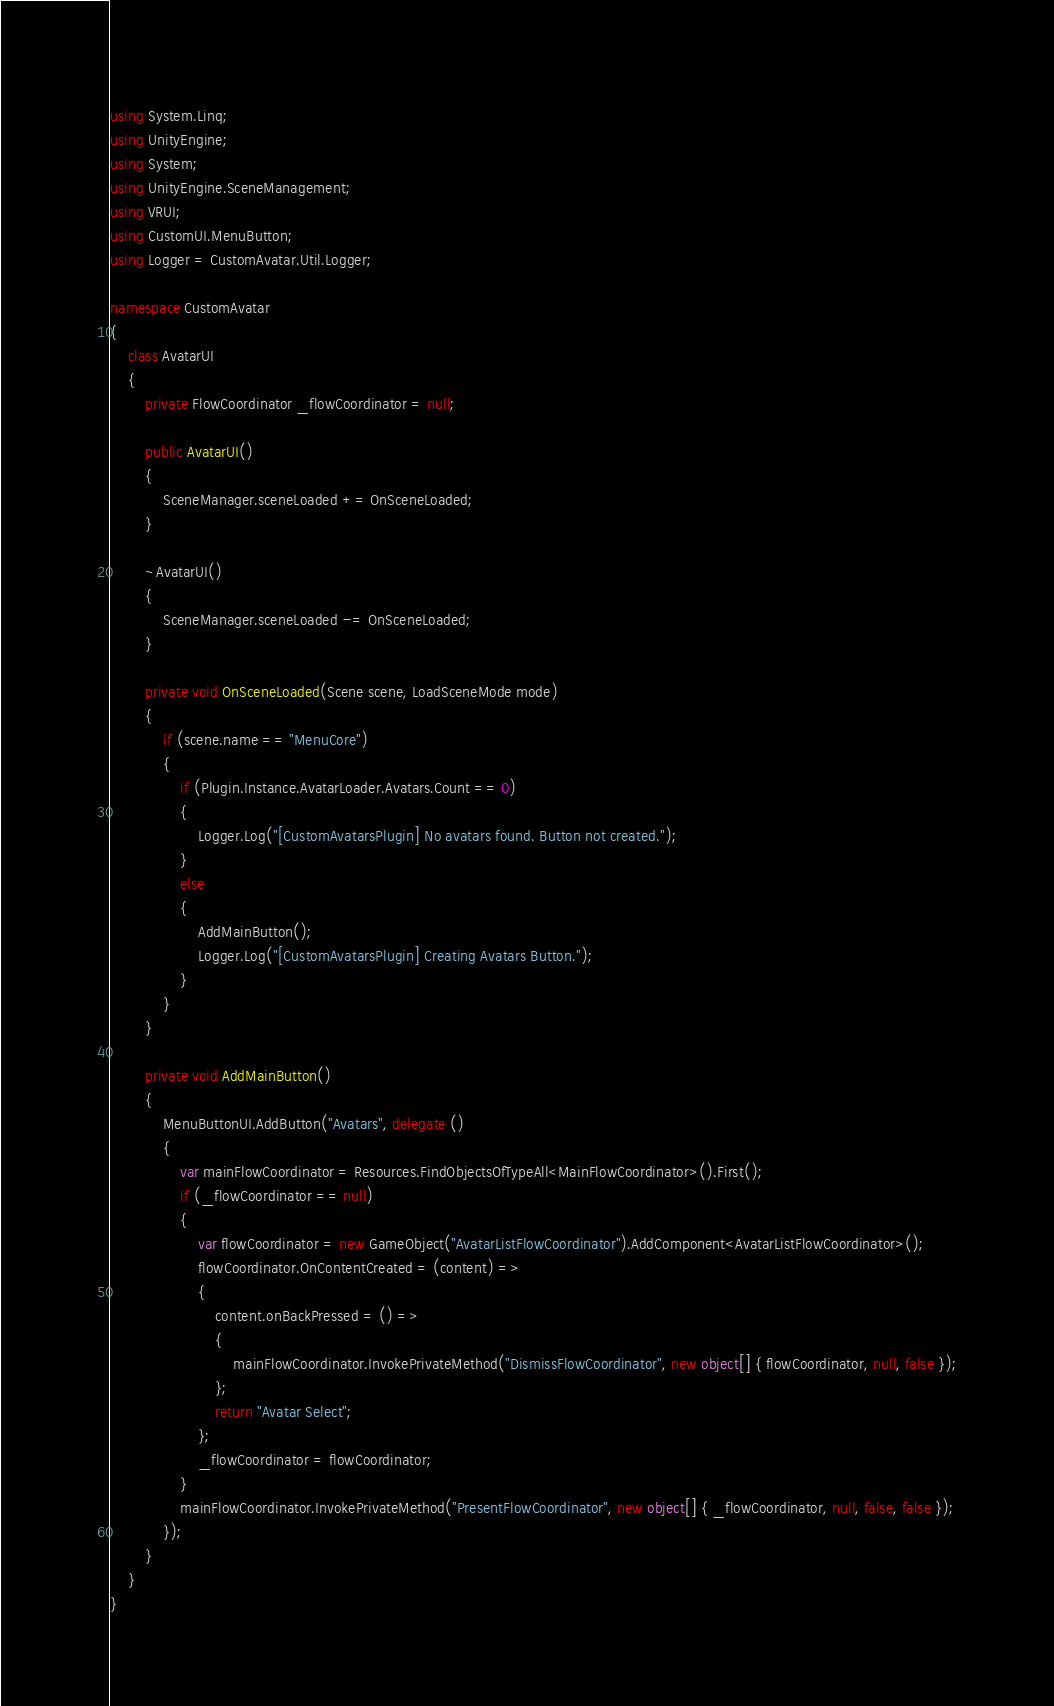<code> <loc_0><loc_0><loc_500><loc_500><_C#_>using System.Linq;
using UnityEngine;
using System;
using UnityEngine.SceneManagement;
using VRUI;
using CustomUI.MenuButton;
using Logger = CustomAvatar.Util.Logger;

namespace CustomAvatar
{
	class AvatarUI
	{
		private FlowCoordinator _flowCoordinator = null;

		public AvatarUI()
		{
			SceneManager.sceneLoaded += OnSceneLoaded;
		}

		~AvatarUI()
		{
			SceneManager.sceneLoaded -= OnSceneLoaded;
		}

		private void OnSceneLoaded(Scene scene, LoadSceneMode mode)
		{
			if (scene.name == "MenuCore")
			{
				if (Plugin.Instance.AvatarLoader.Avatars.Count == 0)
				{
					Logger.Log("[CustomAvatarsPlugin] No avatars found. Button not created.");
				}
				else
				{
					AddMainButton();
					Logger.Log("[CustomAvatarsPlugin] Creating Avatars Button.");
				}
			}
		}

		private void AddMainButton()
		{
			MenuButtonUI.AddButton("Avatars", delegate ()
			{
				var mainFlowCoordinator = Resources.FindObjectsOfTypeAll<MainFlowCoordinator>().First();
				if (_flowCoordinator == null)
				{
					var flowCoordinator = new GameObject("AvatarListFlowCoordinator").AddComponent<AvatarListFlowCoordinator>();
					flowCoordinator.OnContentCreated = (content) =>
					{
						content.onBackPressed = () =>
						{
							mainFlowCoordinator.InvokePrivateMethod("DismissFlowCoordinator", new object[] { flowCoordinator, null, false });
						};
						return "Avatar Select";
					};
					_flowCoordinator = flowCoordinator;
				}
				mainFlowCoordinator.InvokePrivateMethod("PresentFlowCoordinator", new object[] { _flowCoordinator, null, false, false });
			});
		}
	}
}
</code> 